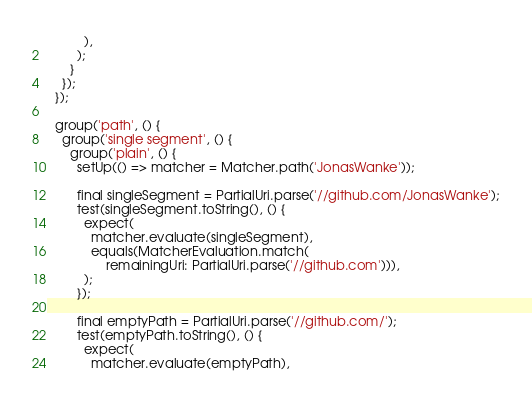<code> <loc_0><loc_0><loc_500><loc_500><_Dart_>          ),
        );
      }
    });
  });

  group('path', () {
    group('single segment', () {
      group('plain', () {
        setUp(() => matcher = Matcher.path('JonasWanke'));

        final singleSegment = PartialUri.parse('//github.com/JonasWanke');
        test(singleSegment.toString(), () {
          expect(
            matcher.evaluate(singleSegment),
            equals(MatcherEvaluation.match(
                remainingUri: PartialUri.parse('//github.com'))),
          );
        });

        final emptyPath = PartialUri.parse('//github.com/');
        test(emptyPath.toString(), () {
          expect(
            matcher.evaluate(emptyPath),</code> 